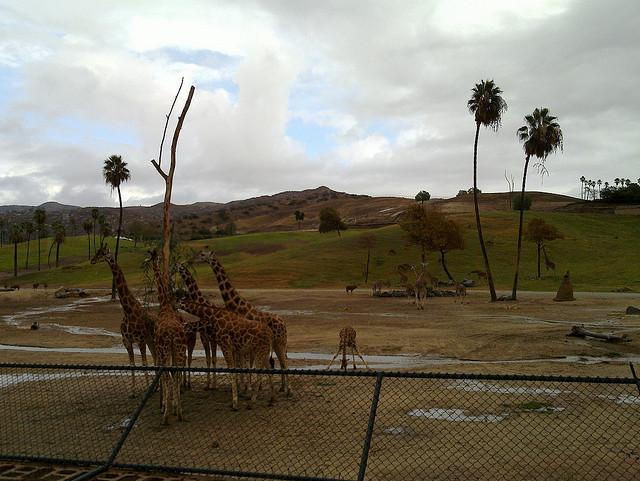What type of enclosure is shown?

Choices:
A) fence
B) barn
C) cage
D) gate fence 